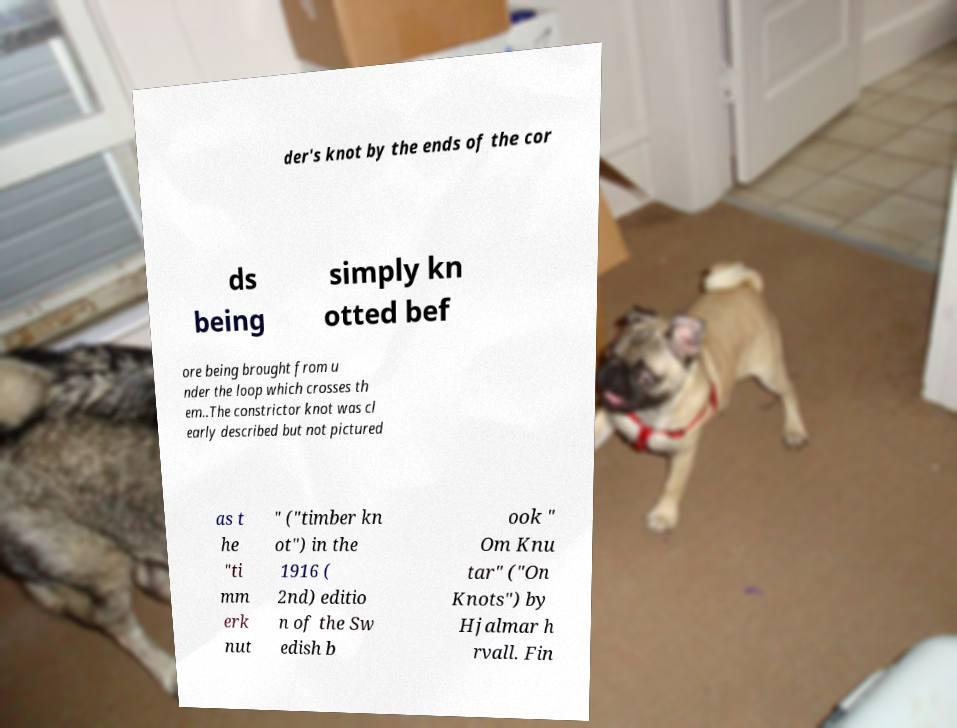Could you extract and type out the text from this image? der's knot by the ends of the cor ds being simply kn otted bef ore being brought from u nder the loop which crosses th em..The constrictor knot was cl early described but not pictured as t he "ti mm erk nut " ("timber kn ot") in the 1916 ( 2nd) editio n of the Sw edish b ook " Om Knu tar" ("On Knots") by Hjalmar h rvall. Fin 